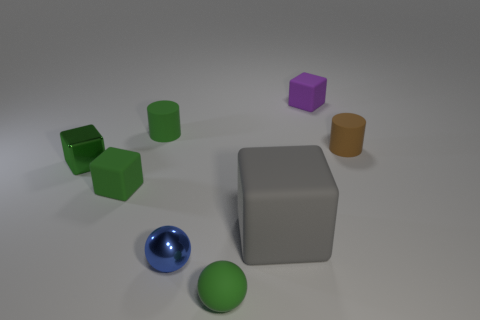Subtract 1 blocks. How many blocks are left? 3 Subtract all blue blocks. Subtract all red cylinders. How many blocks are left? 4 Add 1 brown metallic cylinders. How many objects exist? 9 Subtract all cylinders. How many objects are left? 6 Subtract all green rubber blocks. Subtract all tiny blue objects. How many objects are left? 6 Add 2 small green rubber blocks. How many small green rubber blocks are left? 3 Add 1 tiny matte cylinders. How many tiny matte cylinders exist? 3 Subtract 0 yellow spheres. How many objects are left? 8 